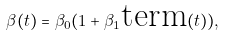Convert formula to latex. <formula><loc_0><loc_0><loc_500><loc_500>\beta ( t ) = \beta _ { 0 } ( 1 + \beta _ { 1 } \text {term} ( t ) ) ,</formula> 